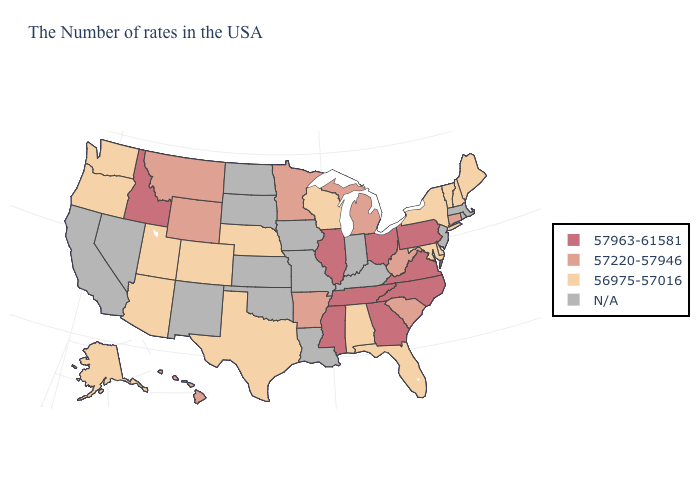What is the value of Hawaii?
Write a very short answer. 57220-57946. Among the states that border Nevada , does Idaho have the highest value?
Short answer required. Yes. What is the value of South Carolina?
Concise answer only. 57220-57946. Does the map have missing data?
Write a very short answer. Yes. Name the states that have a value in the range N/A?
Write a very short answer. Massachusetts, Rhode Island, New Jersey, Kentucky, Indiana, Louisiana, Missouri, Iowa, Kansas, Oklahoma, South Dakota, North Dakota, New Mexico, Nevada, California. What is the lowest value in the USA?
Quick response, please. 56975-57016. Does Minnesota have the lowest value in the USA?
Concise answer only. No. Name the states that have a value in the range N/A?
Quick response, please. Massachusetts, Rhode Island, New Jersey, Kentucky, Indiana, Louisiana, Missouri, Iowa, Kansas, Oklahoma, South Dakota, North Dakota, New Mexico, Nevada, California. Name the states that have a value in the range 57220-57946?
Answer briefly. Connecticut, South Carolina, West Virginia, Michigan, Arkansas, Minnesota, Wyoming, Montana, Hawaii. How many symbols are there in the legend?
Give a very brief answer. 4. What is the value of Colorado?
Keep it brief. 56975-57016. Among the states that border New York , does Pennsylvania have the lowest value?
Keep it brief. No. Is the legend a continuous bar?
Concise answer only. No. Does the map have missing data?
Be succinct. Yes. Is the legend a continuous bar?
Give a very brief answer. No. 